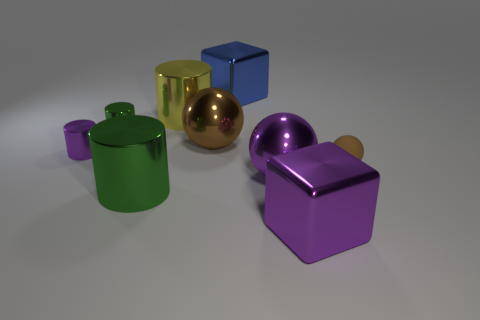There is a brown ball that is to the right of the large brown shiny thing; what is it made of?
Your response must be concise. Rubber. There is a big blue metallic thing; is its shape the same as the purple object that is in front of the large green object?
Give a very brief answer. Yes. Is the number of blue cubes greater than the number of cylinders?
Offer a very short reply. No. Are there any other things of the same color as the small sphere?
Make the answer very short. Yes. There is a large green object that is the same material as the small green cylinder; what shape is it?
Your response must be concise. Cylinder. What material is the tiny thing that is right of the purple metal thing in front of the large green cylinder made of?
Your answer should be very brief. Rubber. Is the shape of the purple shiny thing left of the brown shiny sphere the same as  the big yellow object?
Your answer should be compact. Yes. Is the number of rubber objects on the right side of the rubber ball greater than the number of big metallic things?
Provide a short and direct response. No. Is there anything else that has the same material as the tiny brown sphere?
Make the answer very short. No. The large thing that is the same color as the small matte ball is what shape?
Your response must be concise. Sphere. 